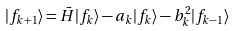Convert formula to latex. <formula><loc_0><loc_0><loc_500><loc_500>| f _ { k + 1 } \rangle = \bar { H } | f _ { k } \rangle - a _ { k } | f _ { k } \rangle - b _ { k } ^ { 2 } | f _ { k - 1 } \rangle</formula> 